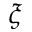<formula> <loc_0><loc_0><loc_500><loc_500>\xi</formula> 